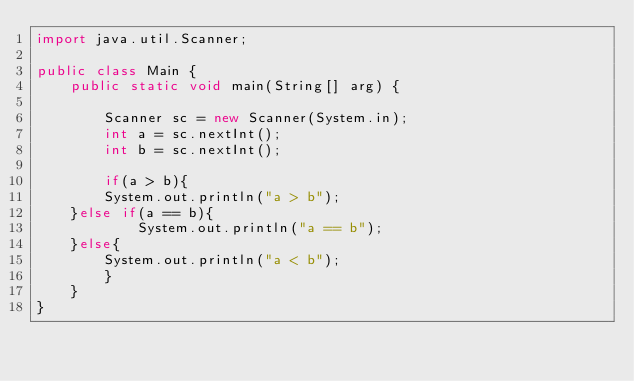Convert code to text. <code><loc_0><loc_0><loc_500><loc_500><_Java_>import java.util.Scanner;

public class Main {
    public static void main(String[] arg) {
        
        Scanner sc = new Scanner(System.in);
        int a = sc.nextInt();
        int b = sc.nextInt();

        if(a > b){
        System.out.println("a > b");
    }else if(a == b){
            System.out.println("a == b");
    }else{
        System.out.println("a < b");
        }
    }
}
</code> 